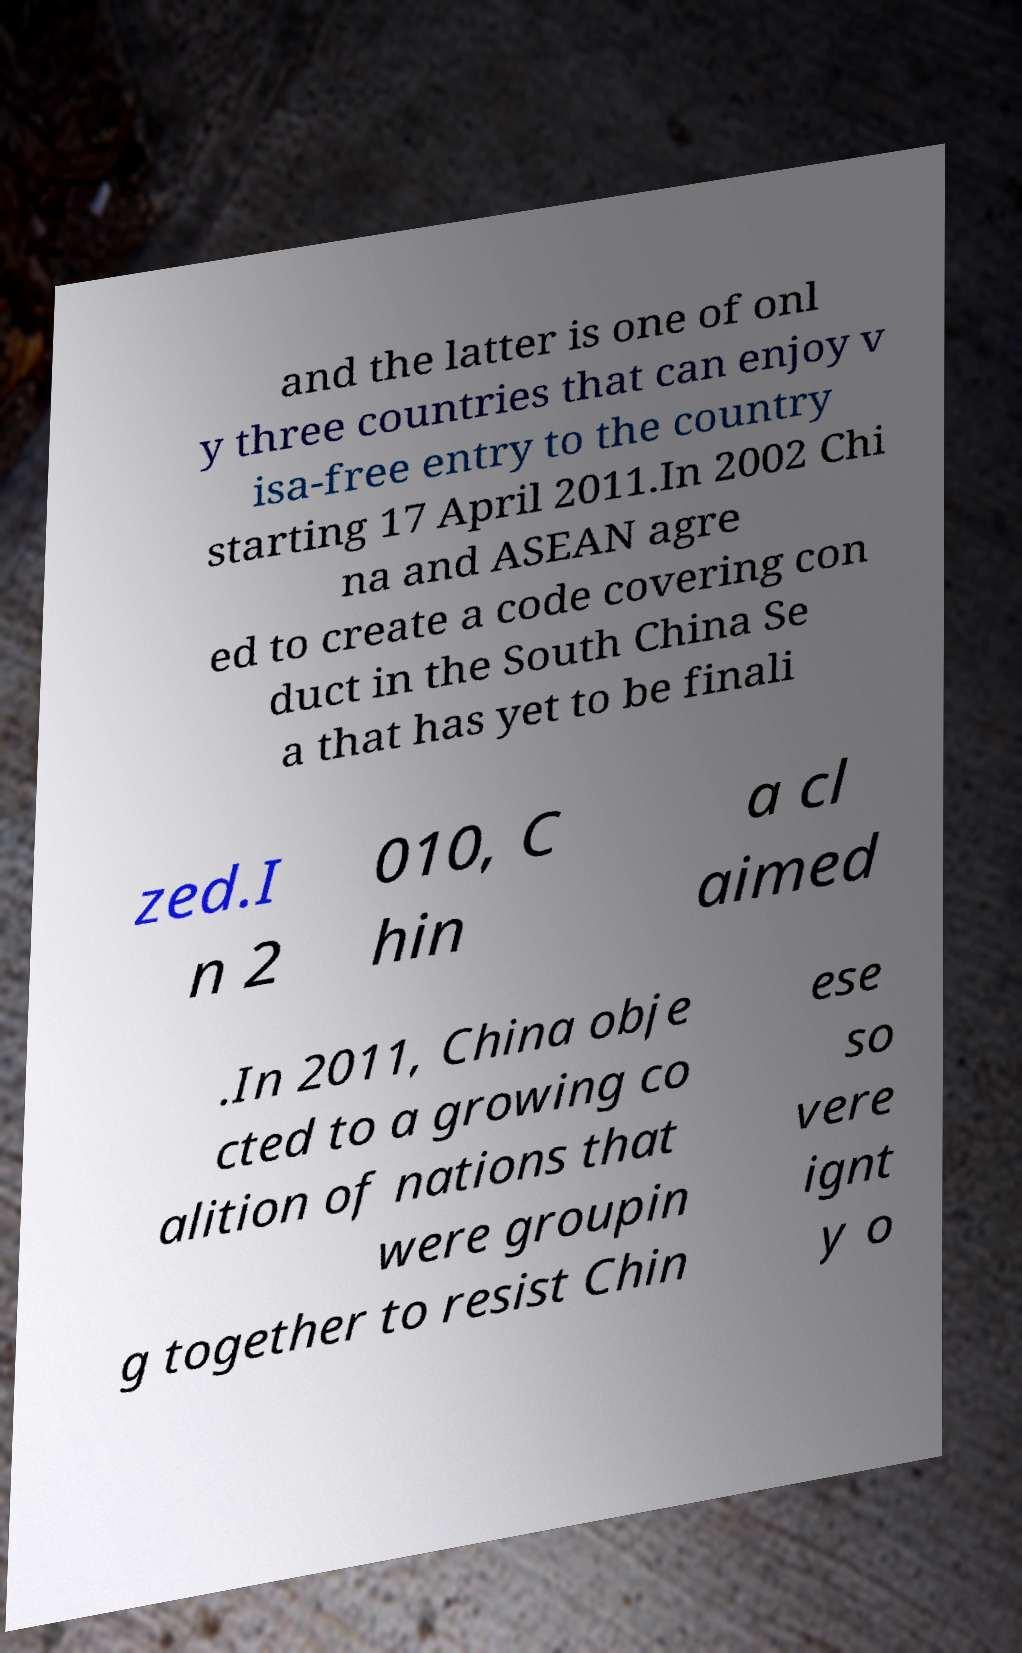Could you assist in decoding the text presented in this image and type it out clearly? and the latter is one of onl y three countries that can enjoy v isa-free entry to the country starting 17 April 2011.In 2002 Chi na and ASEAN agre ed to create a code covering con duct in the South China Se a that has yet to be finali zed.I n 2 010, C hin a cl aimed .In 2011, China obje cted to a growing co alition of nations that were groupin g together to resist Chin ese so vere ignt y o 